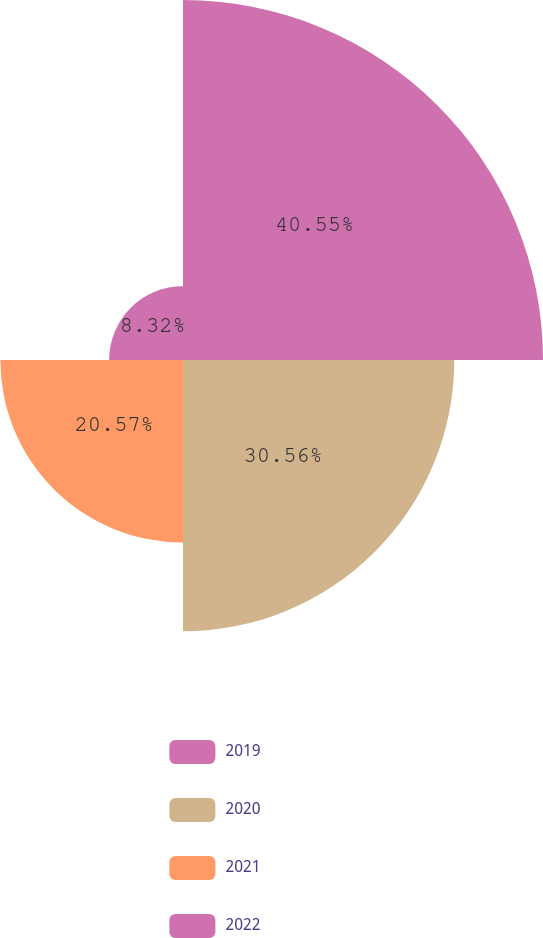Convert chart to OTSL. <chart><loc_0><loc_0><loc_500><loc_500><pie_chart><fcel>2019<fcel>2020<fcel>2021<fcel>2022<nl><fcel>40.55%<fcel>30.56%<fcel>20.57%<fcel>8.32%<nl></chart> 